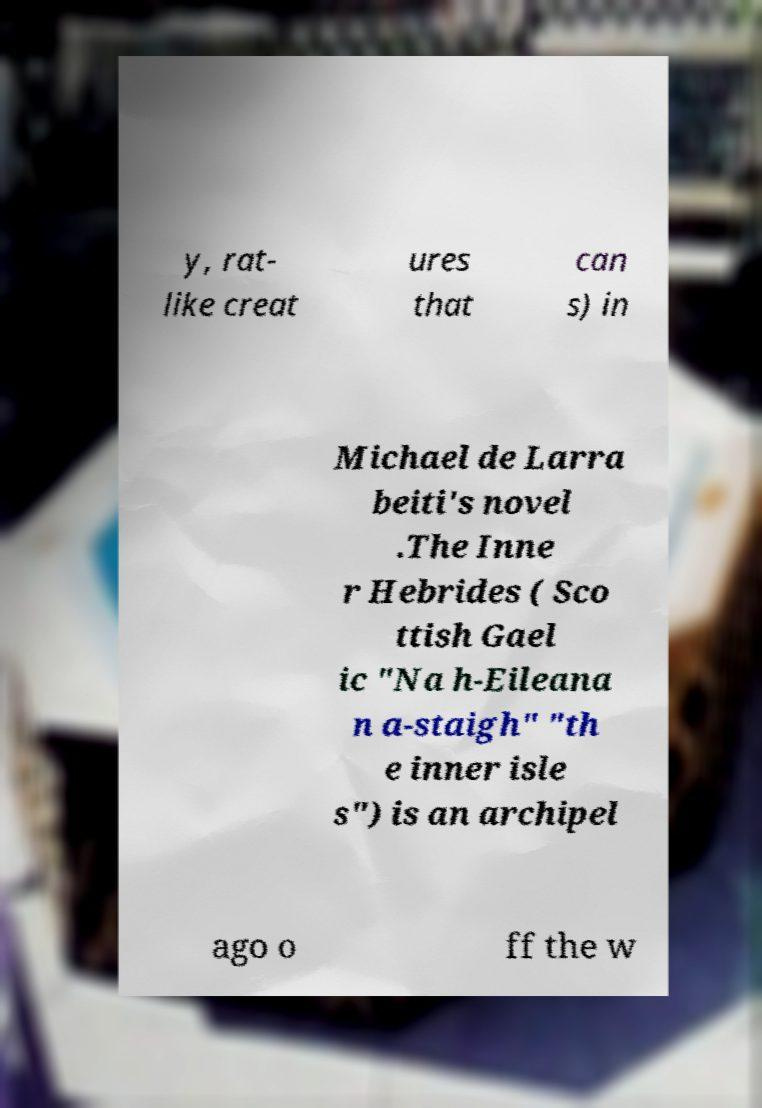Please identify and transcribe the text found in this image. y, rat- like creat ures that can s) in Michael de Larra beiti's novel .The Inne r Hebrides ( Sco ttish Gael ic "Na h-Eileana n a-staigh" "th e inner isle s") is an archipel ago o ff the w 